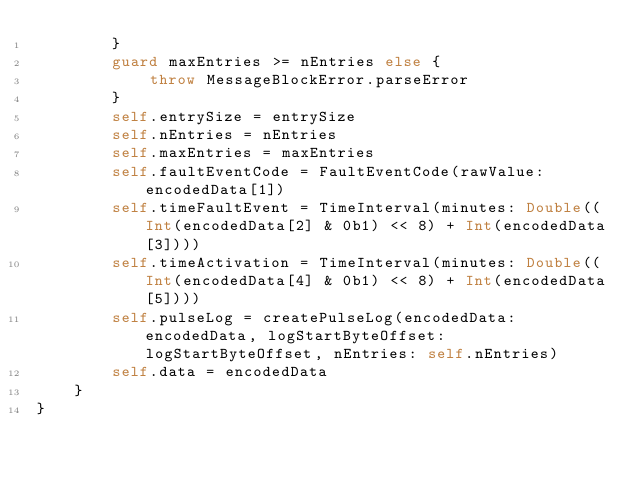<code> <loc_0><loc_0><loc_500><loc_500><_Swift_>        }
        guard maxEntries >= nEntries else {
            throw MessageBlockError.parseError
        }
        self.entrySize = entrySize
        self.nEntries = nEntries
        self.maxEntries = maxEntries
        self.faultEventCode = FaultEventCode(rawValue: encodedData[1])
        self.timeFaultEvent = TimeInterval(minutes: Double((Int(encodedData[2] & 0b1) << 8) + Int(encodedData[3])))
        self.timeActivation = TimeInterval(minutes: Double((Int(encodedData[4] & 0b1) << 8) + Int(encodedData[5])))
        self.pulseLog = createPulseLog(encodedData: encodedData, logStartByteOffset: logStartByteOffset, nEntries: self.nEntries)
        self.data = encodedData
    }
}
</code> 